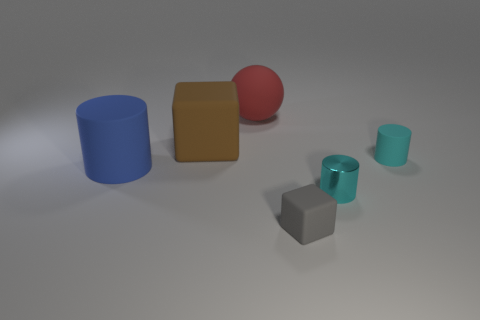Does the shiny cylinder have the same color as the tiny matte cylinder?
Provide a short and direct response. Yes. There is a small metallic cylinder; is its color the same as the matte thing that is to the right of the gray cube?
Offer a very short reply. Yes. There is a tiny object that is behind the thing that is to the left of the large brown rubber object; what is its shape?
Offer a very short reply. Cylinder. What is the size of the rubber thing that is the same color as the shiny cylinder?
Make the answer very short. Small. There is a gray matte object to the right of the red matte ball; is it the same shape as the large brown rubber thing?
Make the answer very short. Yes. Are there more small gray matte cubes that are in front of the big red rubber sphere than large red balls that are on the right side of the gray thing?
Offer a very short reply. Yes. How many cyan things are left of the cyan object that is on the right side of the cyan metallic cylinder?
Offer a very short reply. 1. What is the material of the other tiny cylinder that is the same color as the tiny matte cylinder?
Your answer should be compact. Metal. How many other objects are there of the same color as the ball?
Give a very brief answer. 0. The matte cylinder that is on the left side of the matte thing on the right side of the gray rubber object is what color?
Provide a succinct answer. Blue. 